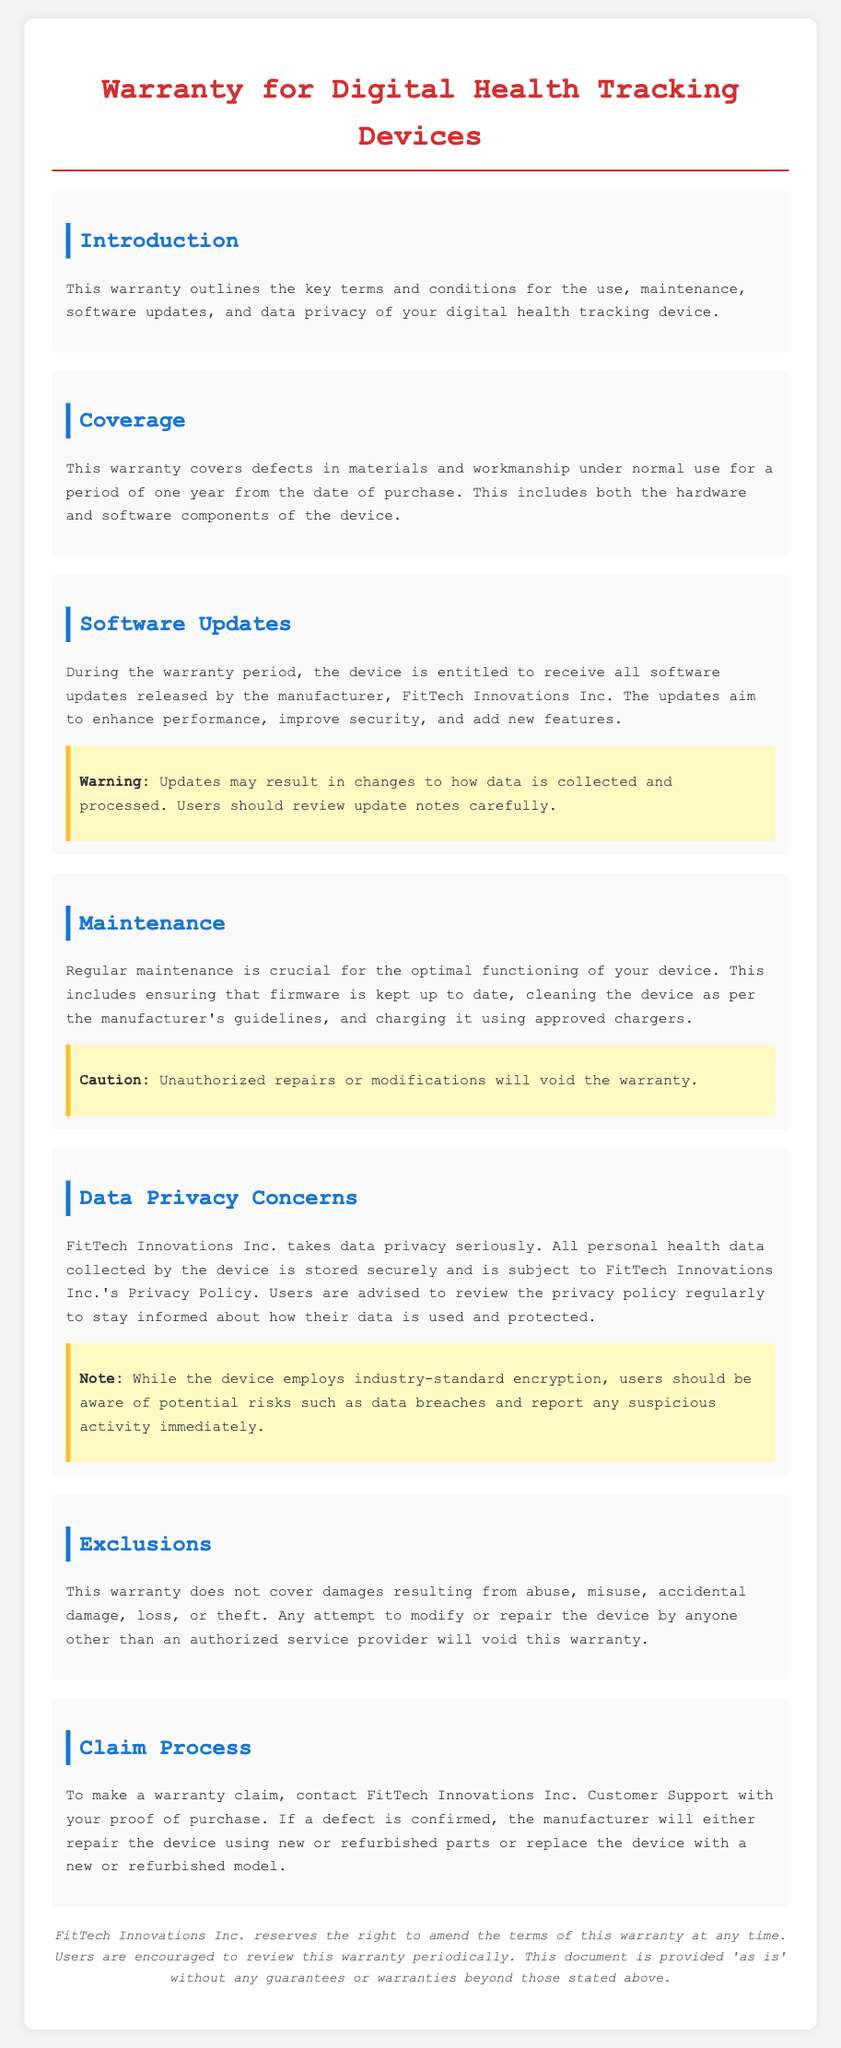what is the warranty period for the device? The warranty period covers defects for a period of one year from the date of purchase.
Answer: one year who is the manufacturer of the device? The document states that the device is manufactured by FitTech Innovations Inc.
Answer: FitTech Innovations Inc what must users do to maintain their device? Regular maintenance includes ensuring firmware is up to date, cleaning the device, and using approved chargers.
Answer: firmware, cleaning, approved chargers what may users experience with software updates? Updates may result in changes to how data is collected and processed, which users should review.
Answer: changes in data collection and processing what should users do if they suspect a data breach? Users should report any suspicious activity immediately, according to the data privacy concerns section.
Answer: report suspicious activity what will void the warranty? The warranty will be voided by unauthorized repairs or modifications of the device.
Answer: unauthorized repairs or modifications where should users direct their warranty claims? Users are advised to contact FitTech Innovations Inc. Customer Support for warranty claims.
Answer: FitTech Innovations Inc. Customer Support what does the warranty not cover? The warranty does not cover damages resulting from abuse, misuse, accidental damage, loss, or theft.
Answer: abuse, misuse, accidental damage, loss, theft 